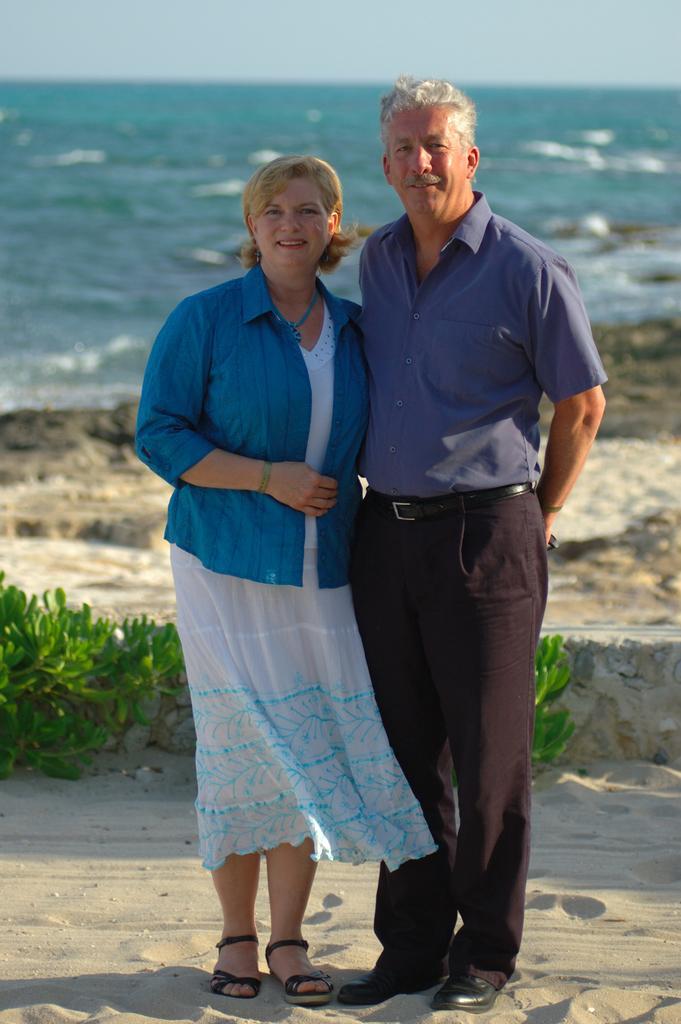Describe this image in one or two sentences. This picture is clicked outside. On the right we can see a man wearing shirt and standing on the sand and we can see a woman wearing white color dress, smiling and standing on the sand. In the background we can see the green leaves, rocks and a water body and some other objects and the sky. 